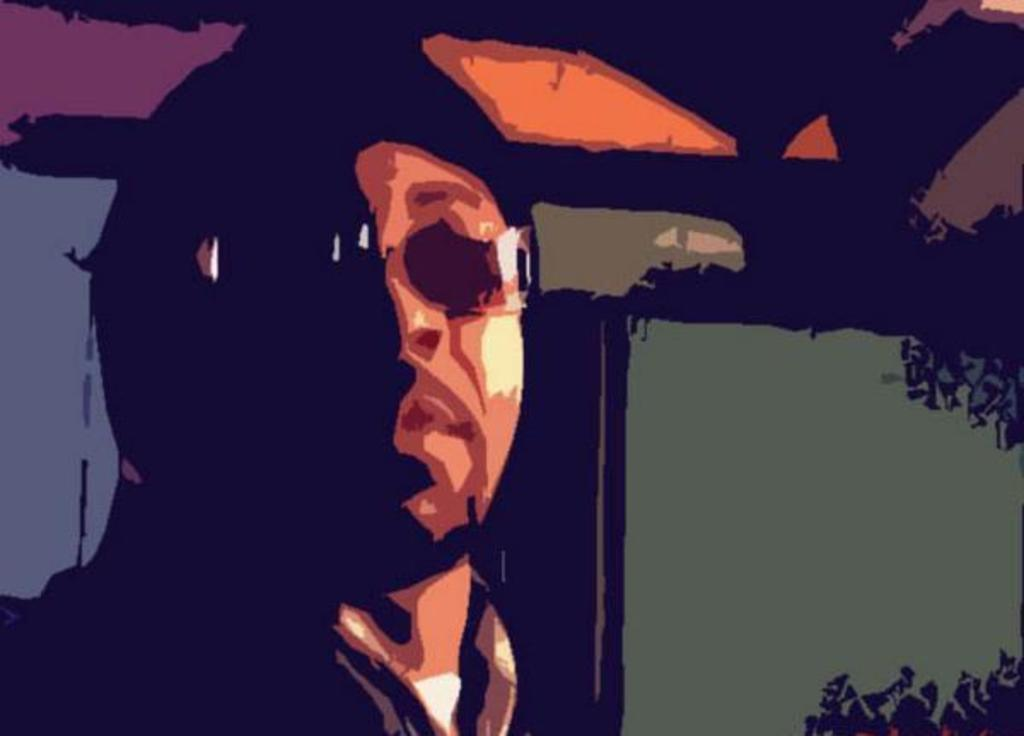What is the main subject of the image? There is a man in the image. Where is the man located in the image? The man is on the left side of the image. Can you describe any accessories the man is wearing? The man appears to be wearing spectacles. What type of glove is the man wearing in the image? There is no glove visible in the image; the man appears to be wearing spectacles. Is the man swimming in the image? There is no indication of swimming in the image; the man is standing on the left side. 